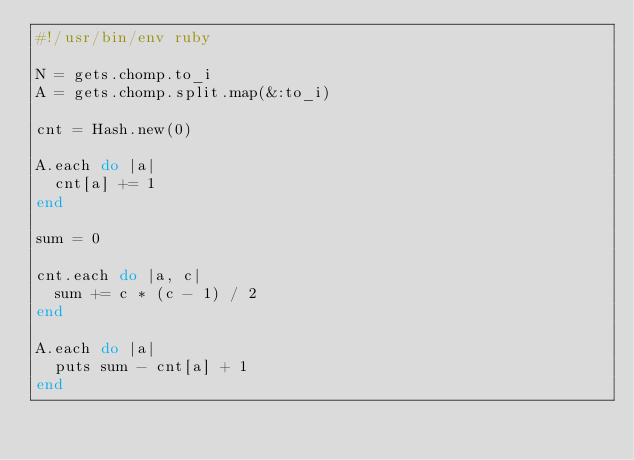<code> <loc_0><loc_0><loc_500><loc_500><_Ruby_>#!/usr/bin/env ruby

N = gets.chomp.to_i
A = gets.chomp.split.map(&:to_i)

cnt = Hash.new(0)

A.each do |a|
  cnt[a] += 1
end

sum = 0

cnt.each do |a, c|
  sum += c * (c - 1) / 2
end

A.each do |a|
  puts sum - cnt[a] + 1
end
</code> 